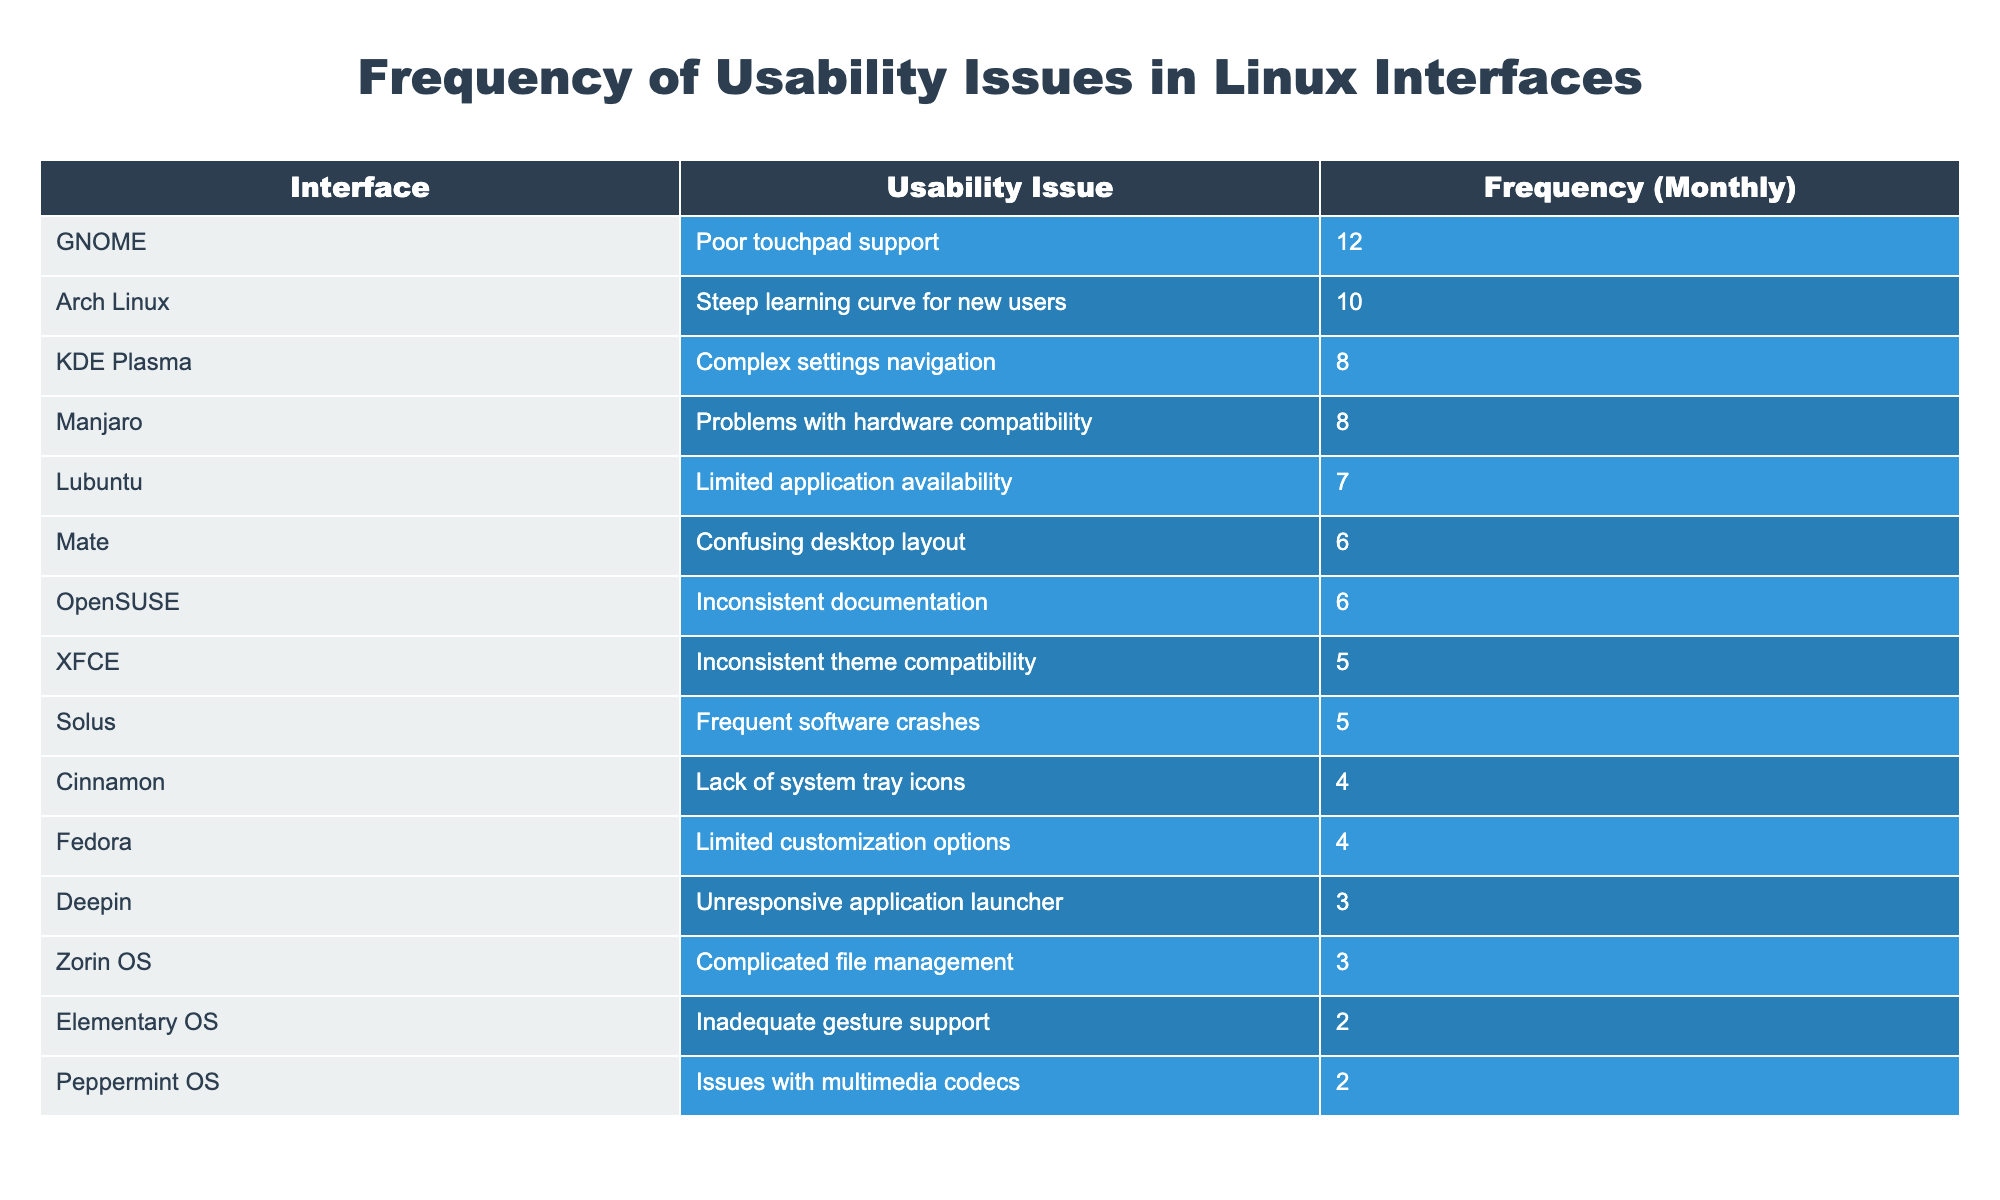What is the most reported usability issue in the table? The table lists the usability issues and their frequencies. By scanning down the Frequency (Monthly) column, the highest value is 12, associated with the issue 'Poor touchpad support' in the GNOME interface.
Answer: Poor touchpad support How many interfaces report a frequency of 6 or more? By counting all the entries where frequency is 6 or greater, we find six such interfaces: GNOME, Arch Linux, KDE Plasma, Mate, OpenSUSE, and Manjaro.
Answer: 6 Which interface has the lowest reported issue frequency, and what is that frequency? By examining the table, the lowest frequency is associated with 'Elementary OS' and 'Peppermint OS', both reporting a frequency of 2. The question asks for one, so I can choose Elementary OS.
Answer: Elementary OS, 2 What is the frequency difference between the highest and lowest reported usability issues? The highest frequency is 12 (GNOME) and the lowest frequency is 2 (Elementary OS). The difference is 12 - 2 = 10.
Answer: 10 Is there an interface with less than 4 reported usability issues? Searching through the frequencies, 'Deepin' (3), 'Zorin OS' (3), and 'Elementary OS' (2) report less than 4 issues. Therefore, the answer is yes.
Answer: Yes What is the average frequency of usability issues across all listed interfaces? First, we sum up all frequencies: 12 + 8 + 5 + 7 + 4 + 6 + 3 + 2 + 10 + 5 + 4 + 6 + 3 + 2 + 8 = 81. There are 15 interfaces, so the average is 81/15 = 5.4.
Answer: 5.4 Which usability issue has a frequency of 4, and how many such issues are there? Upon reviewing the table, the issues with a frequency of 4 are 'Cinnamon, Lack of system tray icons' and 'Fedora, Limited customization options'. There are two issues.
Answer: 2 What percentage of interfaces report a frequency greater than 5? Out of 15 interfaces, 6 report greater than 5 (GNOME, KDE Plasma, Arch Linux, Manjaro, Mate, and OpenSUSE). Thus, the percentage is (6/15) * 100 = 40%.
Answer: 40% Are there more interfaces with usability issues related to stability (software crashes, unresponsive applications) than those related to user interface complexity? Stability-related issues: Solus (5, crashes) and Deepin (3, unresponsive), totaling 2. Complexity-related issues include KDE Plasma (8), Cinnamon (4), and Zorin OS (3), totaling 3. Since 2 < 3, the answer is no.
Answer: No 